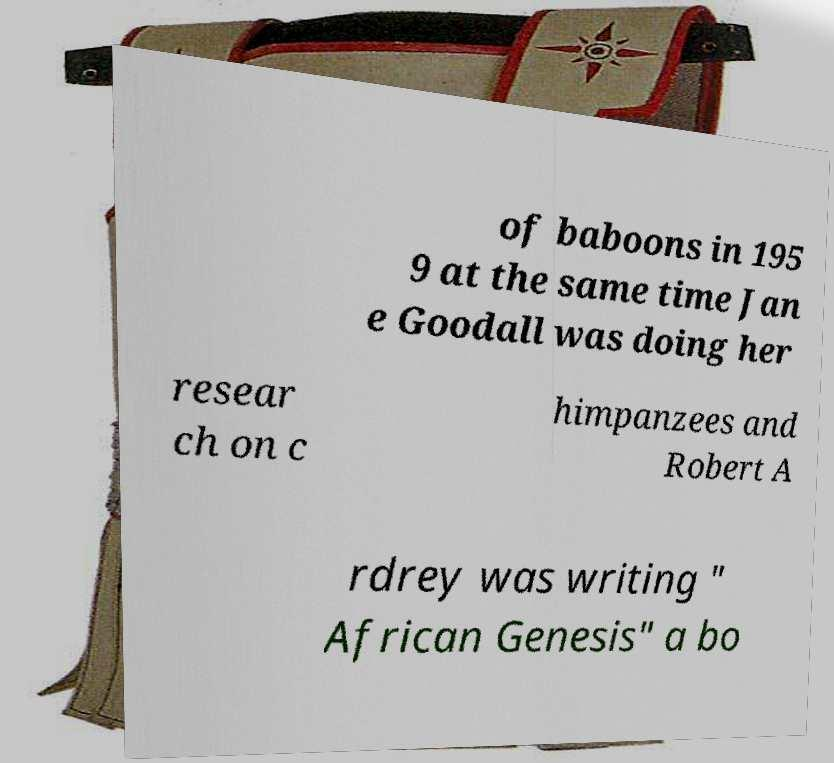Please read and relay the text visible in this image. What does it say? of baboons in 195 9 at the same time Jan e Goodall was doing her resear ch on c himpanzees and Robert A rdrey was writing " African Genesis" a bo 